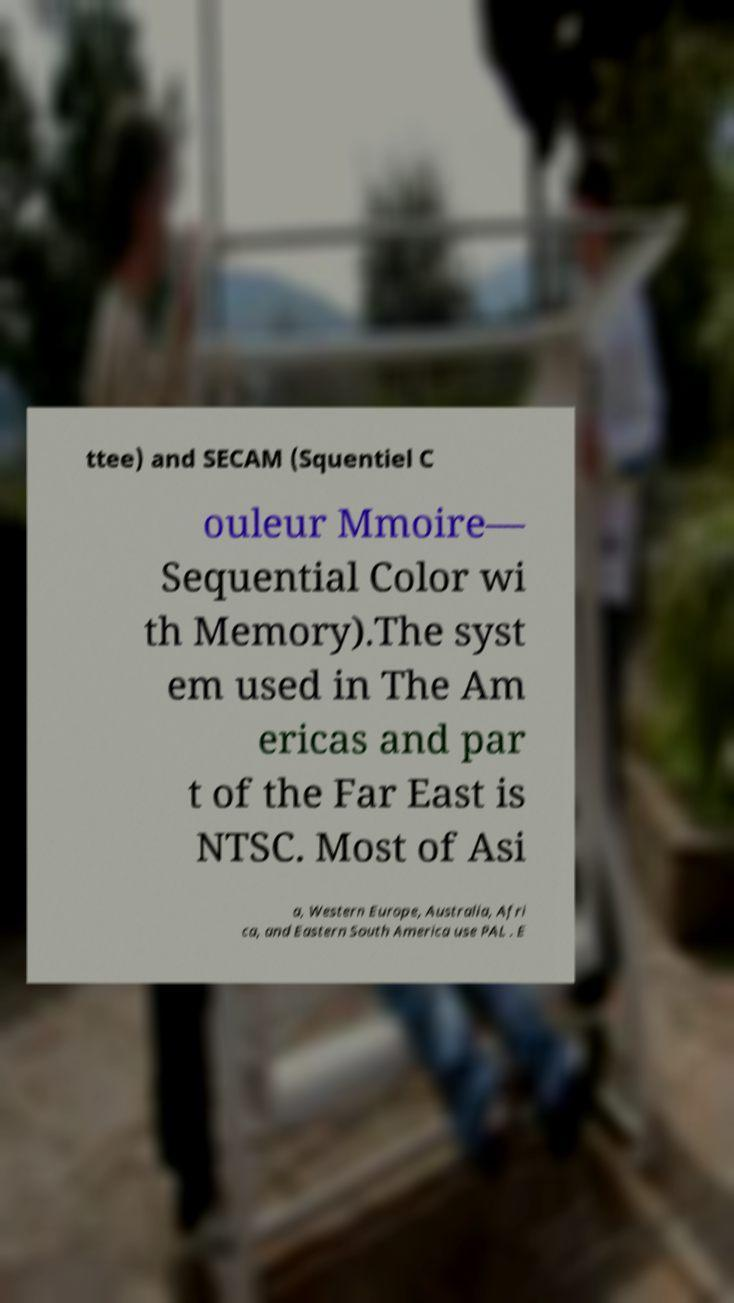Could you assist in decoding the text presented in this image and type it out clearly? ttee) and SECAM (Squentiel C ouleur Mmoire— Sequential Color wi th Memory).The syst em used in The Am ericas and par t of the Far East is NTSC. Most of Asi a, Western Europe, Australia, Afri ca, and Eastern South America use PAL . E 